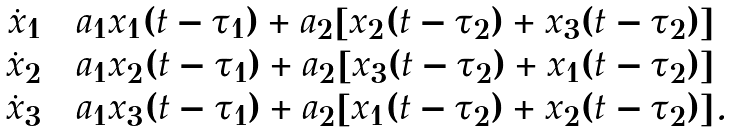Convert formula to latex. <formula><loc_0><loc_0><loc_500><loc_500>\begin{array} { r c l } \dot { x } _ { 1 } & = & a _ { 1 } x _ { 1 } ( t - \tau _ { 1 } ) + a _ { 2 } [ x _ { 2 } ( t - \tau _ { 2 } ) + x _ { 3 } ( t - \tau _ { 2 } ) ] \\ \dot { x } _ { 2 } & = & a _ { 1 } x _ { 2 } ( t - \tau _ { 1 } ) + a _ { 2 } [ x _ { 3 } ( t - \tau _ { 2 } ) + x _ { 1 } ( t - \tau _ { 2 } ) ] \\ \dot { x } _ { 3 } & = & a _ { 1 } x _ { 3 } ( t - \tau _ { 1 } ) + a _ { 2 } [ x _ { 1 } ( t - \tau _ { 2 } ) + x _ { 2 } ( t - \tau _ { 2 } ) ] . \end{array}</formula> 